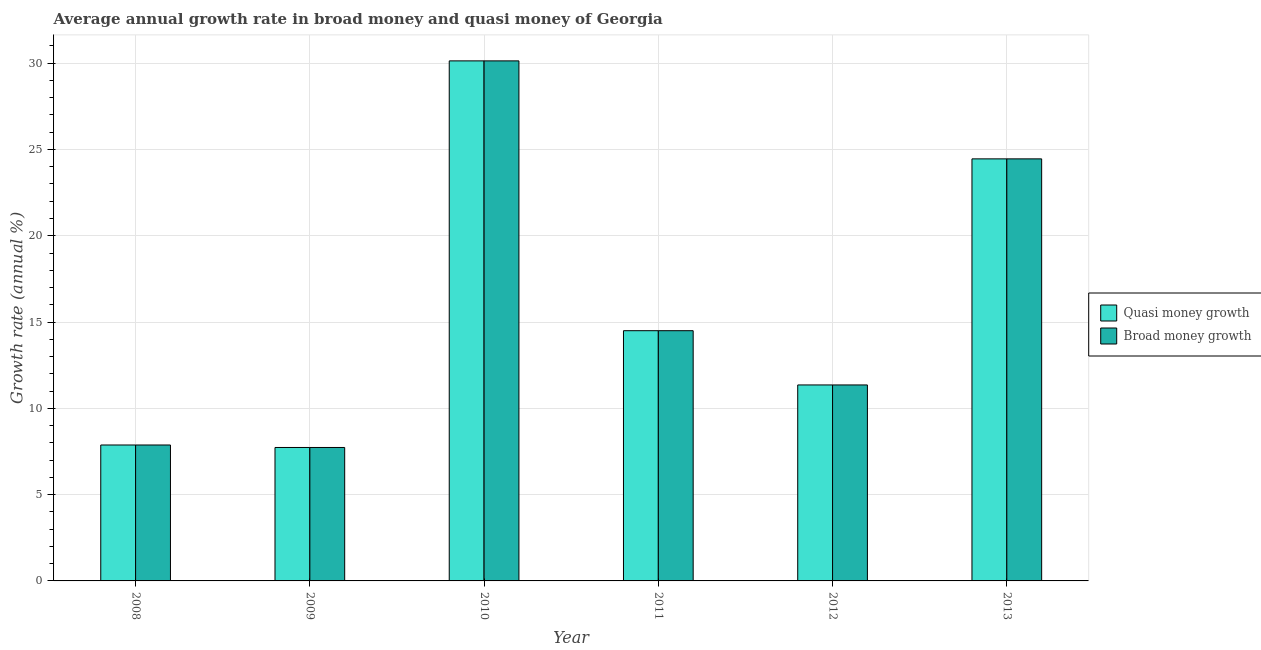How many different coloured bars are there?
Ensure brevity in your answer.  2. How many groups of bars are there?
Give a very brief answer. 6. Are the number of bars per tick equal to the number of legend labels?
Offer a terse response. Yes. How many bars are there on the 1st tick from the right?
Your answer should be very brief. 2. What is the label of the 5th group of bars from the left?
Provide a succinct answer. 2012. In how many cases, is the number of bars for a given year not equal to the number of legend labels?
Provide a succinct answer. 0. What is the annual growth rate in quasi money in 2012?
Make the answer very short. 11.36. Across all years, what is the maximum annual growth rate in broad money?
Make the answer very short. 30.13. Across all years, what is the minimum annual growth rate in broad money?
Offer a very short reply. 7.73. In which year was the annual growth rate in quasi money maximum?
Provide a succinct answer. 2010. What is the total annual growth rate in quasi money in the graph?
Keep it short and to the point. 96.05. What is the difference between the annual growth rate in broad money in 2010 and that in 2011?
Give a very brief answer. 15.63. What is the difference between the annual growth rate in broad money in 2012 and the annual growth rate in quasi money in 2008?
Keep it short and to the point. 3.48. What is the average annual growth rate in broad money per year?
Give a very brief answer. 16.01. In the year 2012, what is the difference between the annual growth rate in quasi money and annual growth rate in broad money?
Offer a very short reply. 0. In how many years, is the annual growth rate in broad money greater than 28 %?
Make the answer very short. 1. What is the ratio of the annual growth rate in broad money in 2010 to that in 2013?
Provide a succinct answer. 1.23. Is the annual growth rate in broad money in 2011 less than that in 2012?
Keep it short and to the point. No. Is the difference between the annual growth rate in quasi money in 2010 and 2012 greater than the difference between the annual growth rate in broad money in 2010 and 2012?
Your response must be concise. No. What is the difference between the highest and the second highest annual growth rate in quasi money?
Provide a short and direct response. 5.68. What is the difference between the highest and the lowest annual growth rate in broad money?
Your response must be concise. 22.4. In how many years, is the annual growth rate in broad money greater than the average annual growth rate in broad money taken over all years?
Ensure brevity in your answer.  2. What does the 2nd bar from the left in 2011 represents?
Your answer should be compact. Broad money growth. What does the 2nd bar from the right in 2011 represents?
Make the answer very short. Quasi money growth. How many years are there in the graph?
Keep it short and to the point. 6. Are the values on the major ticks of Y-axis written in scientific E-notation?
Give a very brief answer. No. Does the graph contain grids?
Your response must be concise. Yes. How many legend labels are there?
Keep it short and to the point. 2. How are the legend labels stacked?
Provide a short and direct response. Vertical. What is the title of the graph?
Your answer should be compact. Average annual growth rate in broad money and quasi money of Georgia. Does "Register a property" appear as one of the legend labels in the graph?
Keep it short and to the point. No. What is the label or title of the Y-axis?
Ensure brevity in your answer.  Growth rate (annual %). What is the Growth rate (annual %) in Quasi money growth in 2008?
Ensure brevity in your answer.  7.88. What is the Growth rate (annual %) in Broad money growth in 2008?
Your answer should be very brief. 7.88. What is the Growth rate (annual %) of Quasi money growth in 2009?
Your answer should be very brief. 7.73. What is the Growth rate (annual %) of Broad money growth in 2009?
Your response must be concise. 7.73. What is the Growth rate (annual %) of Quasi money growth in 2010?
Your response must be concise. 30.13. What is the Growth rate (annual %) of Broad money growth in 2010?
Give a very brief answer. 30.13. What is the Growth rate (annual %) of Quasi money growth in 2011?
Offer a very short reply. 14.5. What is the Growth rate (annual %) of Broad money growth in 2011?
Give a very brief answer. 14.5. What is the Growth rate (annual %) in Quasi money growth in 2012?
Your answer should be very brief. 11.36. What is the Growth rate (annual %) of Broad money growth in 2012?
Your answer should be compact. 11.36. What is the Growth rate (annual %) in Quasi money growth in 2013?
Offer a terse response. 24.46. What is the Growth rate (annual %) of Broad money growth in 2013?
Offer a terse response. 24.46. Across all years, what is the maximum Growth rate (annual %) in Quasi money growth?
Provide a succinct answer. 30.13. Across all years, what is the maximum Growth rate (annual %) in Broad money growth?
Offer a very short reply. 30.13. Across all years, what is the minimum Growth rate (annual %) in Quasi money growth?
Keep it short and to the point. 7.73. Across all years, what is the minimum Growth rate (annual %) of Broad money growth?
Provide a short and direct response. 7.73. What is the total Growth rate (annual %) of Quasi money growth in the graph?
Keep it short and to the point. 96.05. What is the total Growth rate (annual %) of Broad money growth in the graph?
Provide a short and direct response. 96.05. What is the difference between the Growth rate (annual %) in Quasi money growth in 2008 and that in 2009?
Offer a terse response. 0.14. What is the difference between the Growth rate (annual %) in Broad money growth in 2008 and that in 2009?
Give a very brief answer. 0.14. What is the difference between the Growth rate (annual %) in Quasi money growth in 2008 and that in 2010?
Your answer should be compact. -22.26. What is the difference between the Growth rate (annual %) in Broad money growth in 2008 and that in 2010?
Your answer should be very brief. -22.26. What is the difference between the Growth rate (annual %) in Quasi money growth in 2008 and that in 2011?
Your response must be concise. -6.62. What is the difference between the Growth rate (annual %) in Broad money growth in 2008 and that in 2011?
Provide a succinct answer. -6.62. What is the difference between the Growth rate (annual %) of Quasi money growth in 2008 and that in 2012?
Ensure brevity in your answer.  -3.48. What is the difference between the Growth rate (annual %) in Broad money growth in 2008 and that in 2012?
Offer a terse response. -3.48. What is the difference between the Growth rate (annual %) of Quasi money growth in 2008 and that in 2013?
Offer a terse response. -16.58. What is the difference between the Growth rate (annual %) of Broad money growth in 2008 and that in 2013?
Make the answer very short. -16.58. What is the difference between the Growth rate (annual %) in Quasi money growth in 2009 and that in 2010?
Your answer should be very brief. -22.4. What is the difference between the Growth rate (annual %) in Broad money growth in 2009 and that in 2010?
Your answer should be very brief. -22.4. What is the difference between the Growth rate (annual %) in Quasi money growth in 2009 and that in 2011?
Provide a short and direct response. -6.77. What is the difference between the Growth rate (annual %) in Broad money growth in 2009 and that in 2011?
Make the answer very short. -6.77. What is the difference between the Growth rate (annual %) of Quasi money growth in 2009 and that in 2012?
Offer a very short reply. -3.62. What is the difference between the Growth rate (annual %) in Broad money growth in 2009 and that in 2012?
Your answer should be very brief. -3.62. What is the difference between the Growth rate (annual %) in Quasi money growth in 2009 and that in 2013?
Offer a very short reply. -16.72. What is the difference between the Growth rate (annual %) of Broad money growth in 2009 and that in 2013?
Offer a very short reply. -16.72. What is the difference between the Growth rate (annual %) in Quasi money growth in 2010 and that in 2011?
Your response must be concise. 15.63. What is the difference between the Growth rate (annual %) in Broad money growth in 2010 and that in 2011?
Provide a succinct answer. 15.63. What is the difference between the Growth rate (annual %) in Quasi money growth in 2010 and that in 2012?
Offer a terse response. 18.78. What is the difference between the Growth rate (annual %) in Broad money growth in 2010 and that in 2012?
Keep it short and to the point. 18.78. What is the difference between the Growth rate (annual %) in Quasi money growth in 2010 and that in 2013?
Make the answer very short. 5.68. What is the difference between the Growth rate (annual %) in Broad money growth in 2010 and that in 2013?
Offer a terse response. 5.68. What is the difference between the Growth rate (annual %) in Quasi money growth in 2011 and that in 2012?
Your response must be concise. 3.14. What is the difference between the Growth rate (annual %) in Broad money growth in 2011 and that in 2012?
Provide a succinct answer. 3.14. What is the difference between the Growth rate (annual %) in Quasi money growth in 2011 and that in 2013?
Keep it short and to the point. -9.96. What is the difference between the Growth rate (annual %) of Broad money growth in 2011 and that in 2013?
Offer a very short reply. -9.96. What is the difference between the Growth rate (annual %) of Quasi money growth in 2012 and that in 2013?
Keep it short and to the point. -13.1. What is the difference between the Growth rate (annual %) in Broad money growth in 2012 and that in 2013?
Provide a succinct answer. -13.1. What is the difference between the Growth rate (annual %) of Quasi money growth in 2008 and the Growth rate (annual %) of Broad money growth in 2009?
Your answer should be very brief. 0.14. What is the difference between the Growth rate (annual %) of Quasi money growth in 2008 and the Growth rate (annual %) of Broad money growth in 2010?
Give a very brief answer. -22.26. What is the difference between the Growth rate (annual %) in Quasi money growth in 2008 and the Growth rate (annual %) in Broad money growth in 2011?
Ensure brevity in your answer.  -6.62. What is the difference between the Growth rate (annual %) of Quasi money growth in 2008 and the Growth rate (annual %) of Broad money growth in 2012?
Your answer should be very brief. -3.48. What is the difference between the Growth rate (annual %) in Quasi money growth in 2008 and the Growth rate (annual %) in Broad money growth in 2013?
Provide a short and direct response. -16.58. What is the difference between the Growth rate (annual %) of Quasi money growth in 2009 and the Growth rate (annual %) of Broad money growth in 2010?
Offer a terse response. -22.4. What is the difference between the Growth rate (annual %) of Quasi money growth in 2009 and the Growth rate (annual %) of Broad money growth in 2011?
Provide a short and direct response. -6.77. What is the difference between the Growth rate (annual %) of Quasi money growth in 2009 and the Growth rate (annual %) of Broad money growth in 2012?
Offer a very short reply. -3.62. What is the difference between the Growth rate (annual %) of Quasi money growth in 2009 and the Growth rate (annual %) of Broad money growth in 2013?
Provide a short and direct response. -16.72. What is the difference between the Growth rate (annual %) in Quasi money growth in 2010 and the Growth rate (annual %) in Broad money growth in 2011?
Ensure brevity in your answer.  15.63. What is the difference between the Growth rate (annual %) of Quasi money growth in 2010 and the Growth rate (annual %) of Broad money growth in 2012?
Your answer should be very brief. 18.78. What is the difference between the Growth rate (annual %) in Quasi money growth in 2010 and the Growth rate (annual %) in Broad money growth in 2013?
Ensure brevity in your answer.  5.68. What is the difference between the Growth rate (annual %) of Quasi money growth in 2011 and the Growth rate (annual %) of Broad money growth in 2012?
Your answer should be very brief. 3.14. What is the difference between the Growth rate (annual %) of Quasi money growth in 2011 and the Growth rate (annual %) of Broad money growth in 2013?
Give a very brief answer. -9.96. What is the difference between the Growth rate (annual %) of Quasi money growth in 2012 and the Growth rate (annual %) of Broad money growth in 2013?
Offer a terse response. -13.1. What is the average Growth rate (annual %) of Quasi money growth per year?
Ensure brevity in your answer.  16.01. What is the average Growth rate (annual %) of Broad money growth per year?
Keep it short and to the point. 16.01. In the year 2009, what is the difference between the Growth rate (annual %) in Quasi money growth and Growth rate (annual %) in Broad money growth?
Your answer should be compact. 0. In the year 2010, what is the difference between the Growth rate (annual %) of Quasi money growth and Growth rate (annual %) of Broad money growth?
Keep it short and to the point. 0. In the year 2012, what is the difference between the Growth rate (annual %) of Quasi money growth and Growth rate (annual %) of Broad money growth?
Give a very brief answer. 0. In the year 2013, what is the difference between the Growth rate (annual %) of Quasi money growth and Growth rate (annual %) of Broad money growth?
Your answer should be very brief. 0. What is the ratio of the Growth rate (annual %) of Quasi money growth in 2008 to that in 2009?
Offer a very short reply. 1.02. What is the ratio of the Growth rate (annual %) in Broad money growth in 2008 to that in 2009?
Keep it short and to the point. 1.02. What is the ratio of the Growth rate (annual %) in Quasi money growth in 2008 to that in 2010?
Your answer should be very brief. 0.26. What is the ratio of the Growth rate (annual %) of Broad money growth in 2008 to that in 2010?
Your answer should be very brief. 0.26. What is the ratio of the Growth rate (annual %) of Quasi money growth in 2008 to that in 2011?
Make the answer very short. 0.54. What is the ratio of the Growth rate (annual %) of Broad money growth in 2008 to that in 2011?
Make the answer very short. 0.54. What is the ratio of the Growth rate (annual %) of Quasi money growth in 2008 to that in 2012?
Your answer should be compact. 0.69. What is the ratio of the Growth rate (annual %) of Broad money growth in 2008 to that in 2012?
Provide a succinct answer. 0.69. What is the ratio of the Growth rate (annual %) in Quasi money growth in 2008 to that in 2013?
Your answer should be very brief. 0.32. What is the ratio of the Growth rate (annual %) in Broad money growth in 2008 to that in 2013?
Provide a short and direct response. 0.32. What is the ratio of the Growth rate (annual %) in Quasi money growth in 2009 to that in 2010?
Provide a succinct answer. 0.26. What is the ratio of the Growth rate (annual %) in Broad money growth in 2009 to that in 2010?
Provide a short and direct response. 0.26. What is the ratio of the Growth rate (annual %) in Quasi money growth in 2009 to that in 2011?
Give a very brief answer. 0.53. What is the ratio of the Growth rate (annual %) of Broad money growth in 2009 to that in 2011?
Offer a terse response. 0.53. What is the ratio of the Growth rate (annual %) in Quasi money growth in 2009 to that in 2012?
Keep it short and to the point. 0.68. What is the ratio of the Growth rate (annual %) of Broad money growth in 2009 to that in 2012?
Keep it short and to the point. 0.68. What is the ratio of the Growth rate (annual %) of Quasi money growth in 2009 to that in 2013?
Offer a terse response. 0.32. What is the ratio of the Growth rate (annual %) of Broad money growth in 2009 to that in 2013?
Provide a succinct answer. 0.32. What is the ratio of the Growth rate (annual %) in Quasi money growth in 2010 to that in 2011?
Offer a very short reply. 2.08. What is the ratio of the Growth rate (annual %) in Broad money growth in 2010 to that in 2011?
Give a very brief answer. 2.08. What is the ratio of the Growth rate (annual %) in Quasi money growth in 2010 to that in 2012?
Offer a very short reply. 2.65. What is the ratio of the Growth rate (annual %) of Broad money growth in 2010 to that in 2012?
Make the answer very short. 2.65. What is the ratio of the Growth rate (annual %) of Quasi money growth in 2010 to that in 2013?
Provide a succinct answer. 1.23. What is the ratio of the Growth rate (annual %) in Broad money growth in 2010 to that in 2013?
Your answer should be very brief. 1.23. What is the ratio of the Growth rate (annual %) in Quasi money growth in 2011 to that in 2012?
Make the answer very short. 1.28. What is the ratio of the Growth rate (annual %) in Broad money growth in 2011 to that in 2012?
Your answer should be compact. 1.28. What is the ratio of the Growth rate (annual %) of Quasi money growth in 2011 to that in 2013?
Your answer should be very brief. 0.59. What is the ratio of the Growth rate (annual %) in Broad money growth in 2011 to that in 2013?
Your answer should be very brief. 0.59. What is the ratio of the Growth rate (annual %) in Quasi money growth in 2012 to that in 2013?
Your answer should be very brief. 0.46. What is the ratio of the Growth rate (annual %) of Broad money growth in 2012 to that in 2013?
Offer a very short reply. 0.46. What is the difference between the highest and the second highest Growth rate (annual %) of Quasi money growth?
Provide a succinct answer. 5.68. What is the difference between the highest and the second highest Growth rate (annual %) in Broad money growth?
Give a very brief answer. 5.68. What is the difference between the highest and the lowest Growth rate (annual %) in Quasi money growth?
Keep it short and to the point. 22.4. What is the difference between the highest and the lowest Growth rate (annual %) of Broad money growth?
Your answer should be very brief. 22.4. 